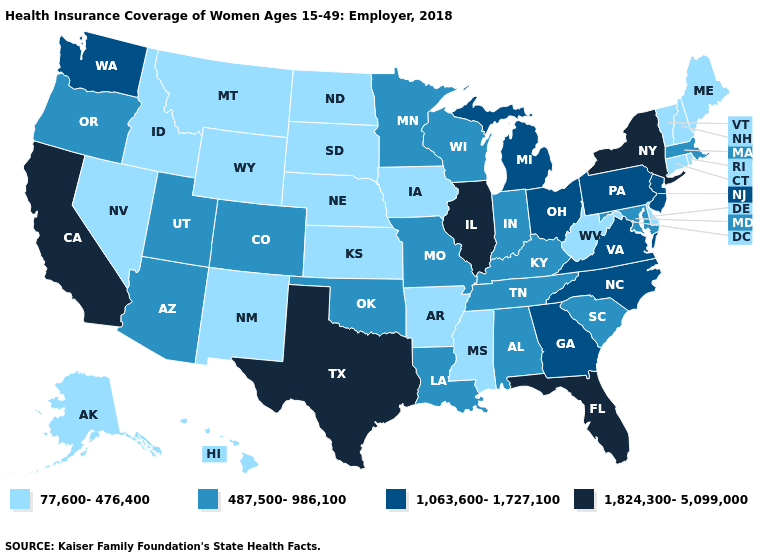What is the value of Minnesota?
Short answer required. 487,500-986,100. What is the value of Pennsylvania?
Be succinct. 1,063,600-1,727,100. Is the legend a continuous bar?
Keep it brief. No. Which states have the lowest value in the USA?
Give a very brief answer. Alaska, Arkansas, Connecticut, Delaware, Hawaii, Idaho, Iowa, Kansas, Maine, Mississippi, Montana, Nebraska, Nevada, New Hampshire, New Mexico, North Dakota, Rhode Island, South Dakota, Vermont, West Virginia, Wyoming. Does Maine have the lowest value in the USA?
Keep it brief. Yes. Name the states that have a value in the range 77,600-476,400?
Answer briefly. Alaska, Arkansas, Connecticut, Delaware, Hawaii, Idaho, Iowa, Kansas, Maine, Mississippi, Montana, Nebraska, Nevada, New Hampshire, New Mexico, North Dakota, Rhode Island, South Dakota, Vermont, West Virginia, Wyoming. Name the states that have a value in the range 77,600-476,400?
Be succinct. Alaska, Arkansas, Connecticut, Delaware, Hawaii, Idaho, Iowa, Kansas, Maine, Mississippi, Montana, Nebraska, Nevada, New Hampshire, New Mexico, North Dakota, Rhode Island, South Dakota, Vermont, West Virginia, Wyoming. What is the lowest value in the Northeast?
Be succinct. 77,600-476,400. Which states have the lowest value in the West?
Give a very brief answer. Alaska, Hawaii, Idaho, Montana, Nevada, New Mexico, Wyoming. Name the states that have a value in the range 77,600-476,400?
Concise answer only. Alaska, Arkansas, Connecticut, Delaware, Hawaii, Idaho, Iowa, Kansas, Maine, Mississippi, Montana, Nebraska, Nevada, New Hampshire, New Mexico, North Dakota, Rhode Island, South Dakota, Vermont, West Virginia, Wyoming. Name the states that have a value in the range 1,063,600-1,727,100?
Short answer required. Georgia, Michigan, New Jersey, North Carolina, Ohio, Pennsylvania, Virginia, Washington. Which states have the highest value in the USA?
Write a very short answer. California, Florida, Illinois, New York, Texas. What is the value of Indiana?
Concise answer only. 487,500-986,100. What is the value of Rhode Island?
Write a very short answer. 77,600-476,400. Among the states that border Maryland , does Delaware have the highest value?
Be succinct. No. 